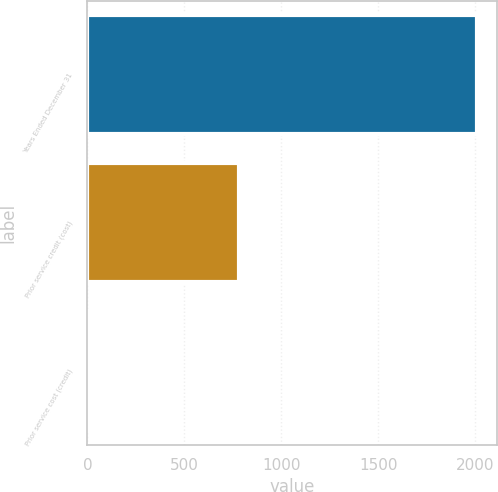Convert chart. <chart><loc_0><loc_0><loc_500><loc_500><bar_chart><fcel>Years Ended December 31<fcel>Prior service credit (cost)<fcel>Prior service cost (credit)<nl><fcel>2011<fcel>783<fcel>5<nl></chart> 